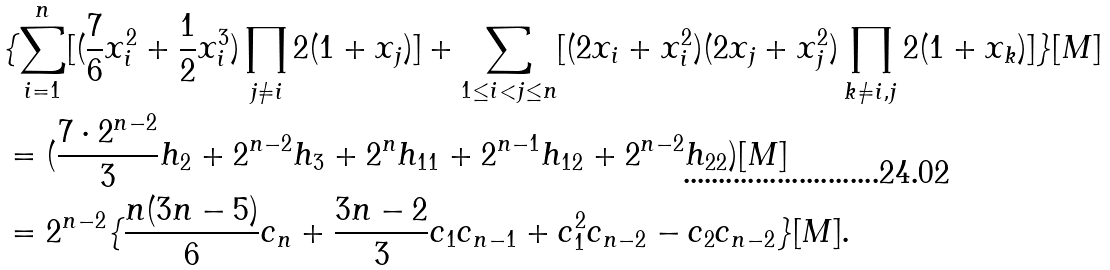<formula> <loc_0><loc_0><loc_500><loc_500>& \{ \sum _ { i = 1 } ^ { n } [ ( \frac { 7 } { 6 } x _ { i } ^ { 2 } + \frac { 1 } { 2 } x _ { i } ^ { 3 } ) \prod _ { j \neq i } 2 ( 1 + x _ { j } ) ] + \sum _ { 1 \leq i < j \leq n } [ ( 2 x _ { i } + x _ { i } ^ { 2 } ) ( 2 x _ { j } + x _ { j } ^ { 2 } ) \prod _ { k \neq i , j } 2 ( 1 + x _ { k } ) ] \} [ M ] \\ & = ( \frac { 7 \cdot 2 ^ { n - 2 } } { 3 } h _ { 2 } + 2 ^ { n - 2 } h _ { 3 } + 2 ^ { n } h _ { 1 1 } + 2 ^ { n - 1 } h _ { 1 2 } + 2 ^ { n - 2 } h _ { 2 2 } ) [ M ] \\ & = 2 ^ { n - 2 } \{ \frac { n ( 3 n - 5 ) } { 6 } c _ { n } + \frac { 3 n - 2 } { 3 } c _ { 1 } c _ { n - 1 } + c _ { 1 } ^ { 2 } c _ { n - 2 } - c _ { 2 } c _ { n - 2 } \} [ M ] .</formula> 